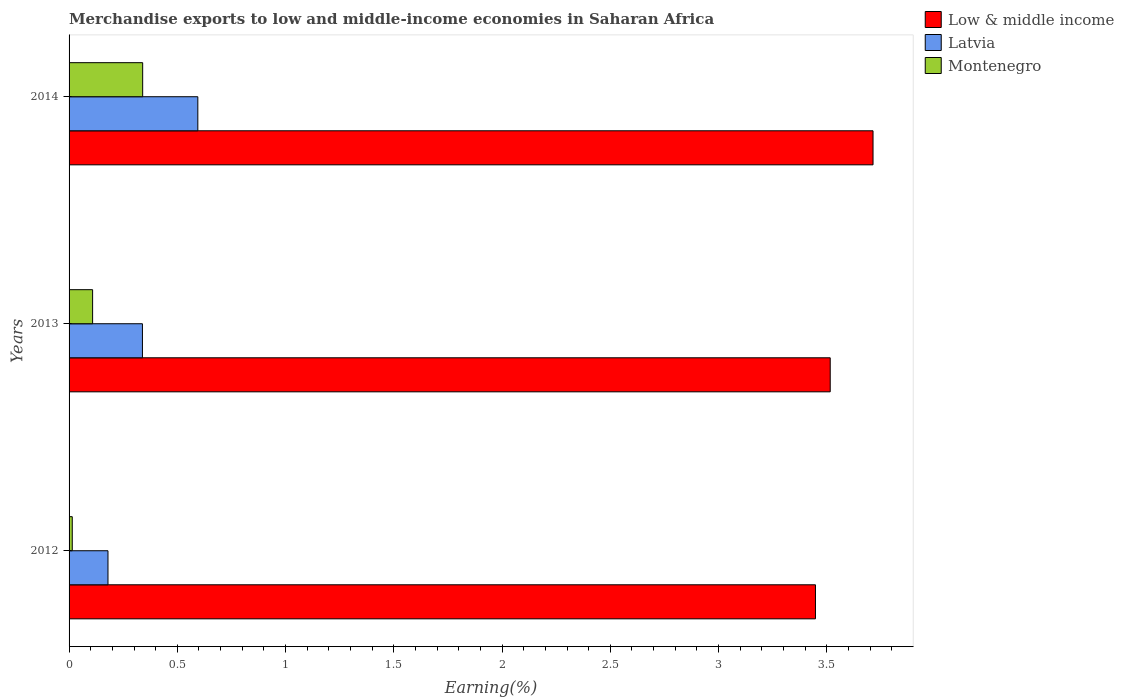Are the number of bars on each tick of the Y-axis equal?
Your response must be concise. Yes. How many bars are there on the 2nd tick from the top?
Provide a succinct answer. 3. What is the percentage of amount earned from merchandise exports in Low & middle income in 2013?
Your response must be concise. 3.52. Across all years, what is the maximum percentage of amount earned from merchandise exports in Montenegro?
Your response must be concise. 0.34. Across all years, what is the minimum percentage of amount earned from merchandise exports in Montenegro?
Your answer should be very brief. 0.01. What is the total percentage of amount earned from merchandise exports in Latvia in the graph?
Provide a short and direct response. 1.11. What is the difference between the percentage of amount earned from merchandise exports in Montenegro in 2012 and that in 2013?
Keep it short and to the point. -0.09. What is the difference between the percentage of amount earned from merchandise exports in Montenegro in 2014 and the percentage of amount earned from merchandise exports in Low & middle income in 2013?
Your response must be concise. -3.18. What is the average percentage of amount earned from merchandise exports in Latvia per year?
Provide a succinct answer. 0.37. In the year 2014, what is the difference between the percentage of amount earned from merchandise exports in Latvia and percentage of amount earned from merchandise exports in Montenegro?
Your answer should be very brief. 0.25. What is the ratio of the percentage of amount earned from merchandise exports in Montenegro in 2013 to that in 2014?
Your answer should be compact. 0.32. Is the percentage of amount earned from merchandise exports in Montenegro in 2013 less than that in 2014?
Provide a short and direct response. Yes. Is the difference between the percentage of amount earned from merchandise exports in Latvia in 2013 and 2014 greater than the difference between the percentage of amount earned from merchandise exports in Montenegro in 2013 and 2014?
Keep it short and to the point. No. What is the difference between the highest and the second highest percentage of amount earned from merchandise exports in Low & middle income?
Your response must be concise. 0.2. What is the difference between the highest and the lowest percentage of amount earned from merchandise exports in Low & middle income?
Ensure brevity in your answer.  0.27. In how many years, is the percentage of amount earned from merchandise exports in Montenegro greater than the average percentage of amount earned from merchandise exports in Montenegro taken over all years?
Offer a terse response. 1. What does the 1st bar from the top in 2012 represents?
Give a very brief answer. Montenegro. What does the 3rd bar from the bottom in 2013 represents?
Offer a terse response. Montenegro. Is it the case that in every year, the sum of the percentage of amount earned from merchandise exports in Latvia and percentage of amount earned from merchandise exports in Low & middle income is greater than the percentage of amount earned from merchandise exports in Montenegro?
Your response must be concise. Yes. How many bars are there?
Provide a succinct answer. 9. What is the difference between two consecutive major ticks on the X-axis?
Keep it short and to the point. 0.5. Are the values on the major ticks of X-axis written in scientific E-notation?
Ensure brevity in your answer.  No. Does the graph contain any zero values?
Your response must be concise. No. Does the graph contain grids?
Your answer should be very brief. No. Where does the legend appear in the graph?
Provide a short and direct response. Top right. How many legend labels are there?
Keep it short and to the point. 3. What is the title of the graph?
Keep it short and to the point. Merchandise exports to low and middle-income economies in Saharan Africa. Does "Fiji" appear as one of the legend labels in the graph?
Make the answer very short. No. What is the label or title of the X-axis?
Provide a succinct answer. Earning(%). What is the label or title of the Y-axis?
Provide a short and direct response. Years. What is the Earning(%) in Low & middle income in 2012?
Offer a very short reply. 3.45. What is the Earning(%) of Latvia in 2012?
Give a very brief answer. 0.18. What is the Earning(%) in Montenegro in 2012?
Give a very brief answer. 0.01. What is the Earning(%) in Low & middle income in 2013?
Make the answer very short. 3.52. What is the Earning(%) in Latvia in 2013?
Offer a terse response. 0.34. What is the Earning(%) of Montenegro in 2013?
Offer a terse response. 0.11. What is the Earning(%) of Low & middle income in 2014?
Make the answer very short. 3.71. What is the Earning(%) in Latvia in 2014?
Offer a very short reply. 0.59. What is the Earning(%) in Montenegro in 2014?
Give a very brief answer. 0.34. Across all years, what is the maximum Earning(%) in Low & middle income?
Provide a succinct answer. 3.71. Across all years, what is the maximum Earning(%) of Latvia?
Provide a short and direct response. 0.59. Across all years, what is the maximum Earning(%) in Montenegro?
Provide a succinct answer. 0.34. Across all years, what is the minimum Earning(%) of Low & middle income?
Keep it short and to the point. 3.45. Across all years, what is the minimum Earning(%) of Latvia?
Your answer should be compact. 0.18. Across all years, what is the minimum Earning(%) in Montenegro?
Offer a very short reply. 0.01. What is the total Earning(%) in Low & middle income in the graph?
Make the answer very short. 10.68. What is the total Earning(%) of Latvia in the graph?
Make the answer very short. 1.11. What is the total Earning(%) of Montenegro in the graph?
Make the answer very short. 0.46. What is the difference between the Earning(%) in Low & middle income in 2012 and that in 2013?
Ensure brevity in your answer.  -0.07. What is the difference between the Earning(%) of Latvia in 2012 and that in 2013?
Offer a terse response. -0.16. What is the difference between the Earning(%) in Montenegro in 2012 and that in 2013?
Ensure brevity in your answer.  -0.09. What is the difference between the Earning(%) in Low & middle income in 2012 and that in 2014?
Your answer should be very brief. -0.27. What is the difference between the Earning(%) of Latvia in 2012 and that in 2014?
Your answer should be compact. -0.41. What is the difference between the Earning(%) in Montenegro in 2012 and that in 2014?
Your answer should be very brief. -0.33. What is the difference between the Earning(%) of Low & middle income in 2013 and that in 2014?
Your answer should be very brief. -0.2. What is the difference between the Earning(%) of Latvia in 2013 and that in 2014?
Offer a very short reply. -0.26. What is the difference between the Earning(%) of Montenegro in 2013 and that in 2014?
Give a very brief answer. -0.23. What is the difference between the Earning(%) of Low & middle income in 2012 and the Earning(%) of Latvia in 2013?
Provide a short and direct response. 3.11. What is the difference between the Earning(%) in Low & middle income in 2012 and the Earning(%) in Montenegro in 2013?
Give a very brief answer. 3.34. What is the difference between the Earning(%) in Latvia in 2012 and the Earning(%) in Montenegro in 2013?
Give a very brief answer. 0.07. What is the difference between the Earning(%) in Low & middle income in 2012 and the Earning(%) in Latvia in 2014?
Keep it short and to the point. 2.85. What is the difference between the Earning(%) of Low & middle income in 2012 and the Earning(%) of Montenegro in 2014?
Your answer should be compact. 3.11. What is the difference between the Earning(%) in Latvia in 2012 and the Earning(%) in Montenegro in 2014?
Offer a terse response. -0.16. What is the difference between the Earning(%) of Low & middle income in 2013 and the Earning(%) of Latvia in 2014?
Make the answer very short. 2.92. What is the difference between the Earning(%) in Low & middle income in 2013 and the Earning(%) in Montenegro in 2014?
Your answer should be compact. 3.18. What is the difference between the Earning(%) of Latvia in 2013 and the Earning(%) of Montenegro in 2014?
Your response must be concise. -0. What is the average Earning(%) in Low & middle income per year?
Provide a succinct answer. 3.56. What is the average Earning(%) of Latvia per year?
Provide a succinct answer. 0.37. What is the average Earning(%) in Montenegro per year?
Make the answer very short. 0.15. In the year 2012, what is the difference between the Earning(%) in Low & middle income and Earning(%) in Latvia?
Your response must be concise. 3.27. In the year 2012, what is the difference between the Earning(%) in Low & middle income and Earning(%) in Montenegro?
Your answer should be very brief. 3.43. In the year 2012, what is the difference between the Earning(%) in Latvia and Earning(%) in Montenegro?
Your answer should be compact. 0.17. In the year 2013, what is the difference between the Earning(%) of Low & middle income and Earning(%) of Latvia?
Ensure brevity in your answer.  3.18. In the year 2013, what is the difference between the Earning(%) of Low & middle income and Earning(%) of Montenegro?
Offer a terse response. 3.41. In the year 2013, what is the difference between the Earning(%) of Latvia and Earning(%) of Montenegro?
Give a very brief answer. 0.23. In the year 2014, what is the difference between the Earning(%) in Low & middle income and Earning(%) in Latvia?
Make the answer very short. 3.12. In the year 2014, what is the difference between the Earning(%) in Low & middle income and Earning(%) in Montenegro?
Offer a terse response. 3.37. In the year 2014, what is the difference between the Earning(%) of Latvia and Earning(%) of Montenegro?
Ensure brevity in your answer.  0.25. What is the ratio of the Earning(%) in Low & middle income in 2012 to that in 2013?
Your response must be concise. 0.98. What is the ratio of the Earning(%) in Latvia in 2012 to that in 2013?
Provide a short and direct response. 0.53. What is the ratio of the Earning(%) in Montenegro in 2012 to that in 2013?
Your answer should be compact. 0.14. What is the ratio of the Earning(%) in Low & middle income in 2012 to that in 2014?
Provide a succinct answer. 0.93. What is the ratio of the Earning(%) in Latvia in 2012 to that in 2014?
Offer a terse response. 0.3. What is the ratio of the Earning(%) in Montenegro in 2012 to that in 2014?
Provide a succinct answer. 0.04. What is the ratio of the Earning(%) in Low & middle income in 2013 to that in 2014?
Keep it short and to the point. 0.95. What is the ratio of the Earning(%) of Latvia in 2013 to that in 2014?
Provide a short and direct response. 0.57. What is the ratio of the Earning(%) of Montenegro in 2013 to that in 2014?
Provide a succinct answer. 0.32. What is the difference between the highest and the second highest Earning(%) of Low & middle income?
Provide a short and direct response. 0.2. What is the difference between the highest and the second highest Earning(%) of Latvia?
Your answer should be compact. 0.26. What is the difference between the highest and the second highest Earning(%) in Montenegro?
Provide a short and direct response. 0.23. What is the difference between the highest and the lowest Earning(%) of Low & middle income?
Keep it short and to the point. 0.27. What is the difference between the highest and the lowest Earning(%) of Latvia?
Offer a very short reply. 0.41. What is the difference between the highest and the lowest Earning(%) in Montenegro?
Ensure brevity in your answer.  0.33. 